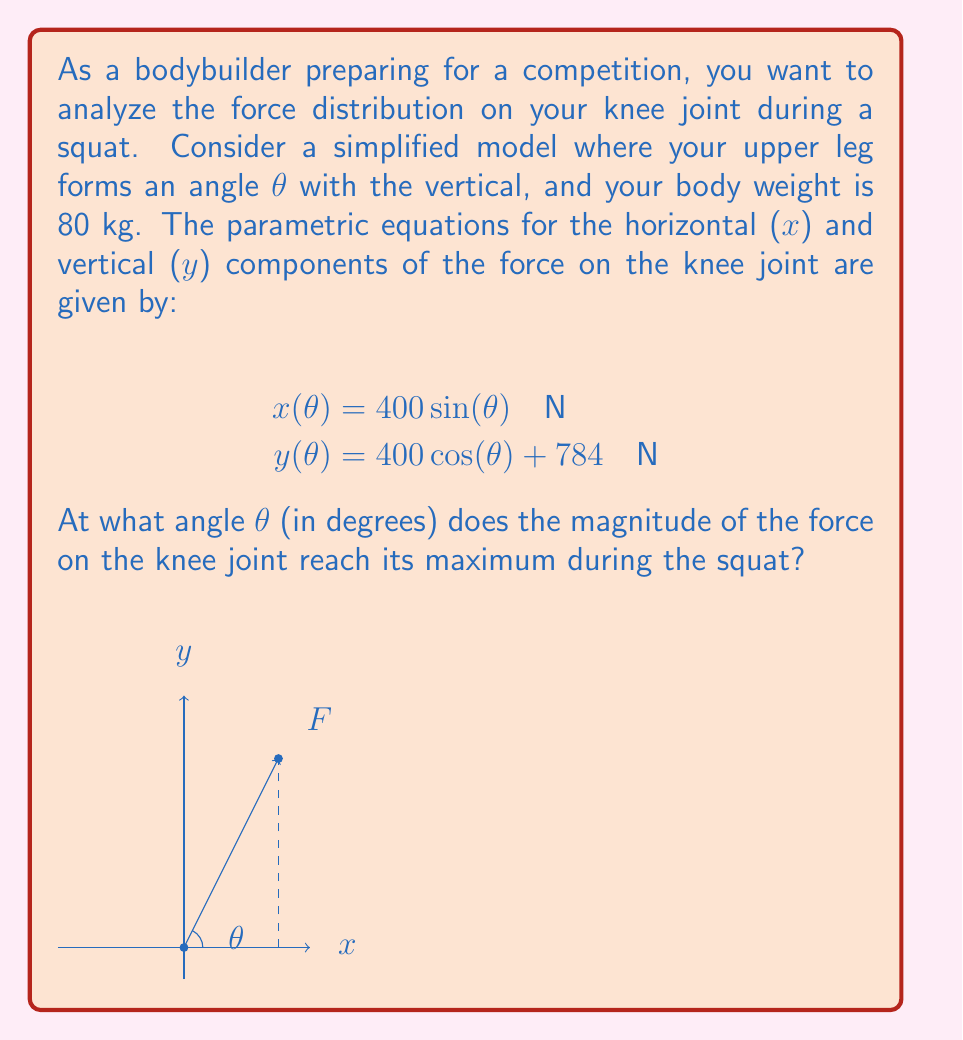Help me with this question. Let's approach this step-by-step:

1) The magnitude of the force F is given by:

   $$F(θ) = \sqrt{x(θ)^2 + y(θ)^2}$$

2) Substituting the given parametric equations:

   $$F(θ) = \sqrt{(400 \sin(θ))^2 + (400 \cos(θ) + 784)^2}$$

3) To find the maximum, we need to differentiate F(θ) with respect to θ and set it to zero:

   $$\frac{dF}{dθ} = \frac{1}{2\sqrt{(400 \sin(θ))^2 + (400 \cos(θ) + 784)^2}} \cdot \frac{d}{dθ}[(400 \sin(θ))^2 + (400 \cos(θ) + 784)^2] = 0$$

4) Simplifying the derivative:

   $$\frac{dF}{dθ} = \frac{400^2 \sin(2θ) - 400 \cdot 784 \sin(θ)}{\sqrt{(400 \sin(θ))^2 + (400 \cos(θ) + 784)^2}} = 0$$

5) For this to be zero, the numerator must be zero:

   $$400^2 \sin(2θ) - 400 \cdot 784 \sin(θ) = 0$$

6) Simplifying:

   $$800 \sin(2θ) - 784 \sin(θ) = 0$$

7) Using the double angle formula $\sin(2θ) = 2\sin(θ)\cos(θ)$:

   $$1600 \sin(θ)\cos(θ) - 784 \sin(θ) = 0$$

8) Factoring out $\sin(θ)$:

   $$\sin(θ)(1600 \cos(θ) - 784) = 0$$

9) This is satisfied when either $\sin(θ) = 0$ or $1600 \cos(θ) - 784 = 0$

10) $\sin(θ) = 0$ occurs at θ = 0° or 180°, which are not within a typical squat range.

11) Solving $1600 \cos(θ) - 784 = 0$:

    $$\cos(θ) = \frac{784}{1600} = 0.49$$

12) Taking the inverse cosine:

    $$θ = \arccos(0.49) \approx 60.64°$$

Therefore, the force on the knee joint reaches its maximum when the upper leg forms an angle of approximately 60.64° with the vertical.
Answer: 60.64° 